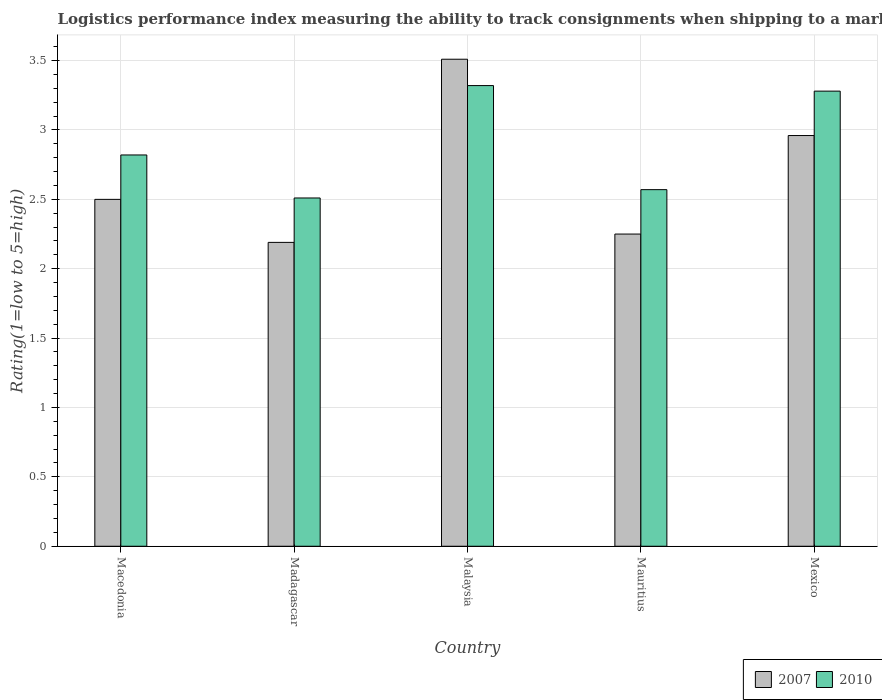How many groups of bars are there?
Provide a short and direct response. 5. How many bars are there on the 1st tick from the left?
Ensure brevity in your answer.  2. How many bars are there on the 1st tick from the right?
Offer a very short reply. 2. What is the label of the 3rd group of bars from the left?
Your answer should be compact. Malaysia. In how many cases, is the number of bars for a given country not equal to the number of legend labels?
Provide a succinct answer. 0. What is the Logistic performance index in 2007 in Mauritius?
Keep it short and to the point. 2.25. Across all countries, what is the maximum Logistic performance index in 2007?
Your answer should be very brief. 3.51. Across all countries, what is the minimum Logistic performance index in 2007?
Provide a short and direct response. 2.19. In which country was the Logistic performance index in 2007 maximum?
Your answer should be very brief. Malaysia. In which country was the Logistic performance index in 2010 minimum?
Give a very brief answer. Madagascar. What is the total Logistic performance index in 2007 in the graph?
Give a very brief answer. 13.41. What is the difference between the Logistic performance index in 2007 in Mauritius and that in Mexico?
Provide a short and direct response. -0.71. What is the difference between the Logistic performance index in 2010 in Macedonia and the Logistic performance index in 2007 in Madagascar?
Your answer should be very brief. 0.63. What is the average Logistic performance index in 2010 per country?
Your response must be concise. 2.9. What is the difference between the Logistic performance index of/in 2010 and Logistic performance index of/in 2007 in Malaysia?
Offer a very short reply. -0.19. In how many countries, is the Logistic performance index in 2007 greater than 2.8?
Ensure brevity in your answer.  2. What is the ratio of the Logistic performance index in 2007 in Mauritius to that in Mexico?
Provide a succinct answer. 0.76. Is the difference between the Logistic performance index in 2010 in Macedonia and Mexico greater than the difference between the Logistic performance index in 2007 in Macedonia and Mexico?
Give a very brief answer. No. What is the difference between the highest and the second highest Logistic performance index in 2010?
Ensure brevity in your answer.  0.46. What is the difference between the highest and the lowest Logistic performance index in 2010?
Give a very brief answer. 0.81. In how many countries, is the Logistic performance index in 2010 greater than the average Logistic performance index in 2010 taken over all countries?
Your answer should be very brief. 2. Is the sum of the Logistic performance index in 2007 in Malaysia and Mexico greater than the maximum Logistic performance index in 2010 across all countries?
Ensure brevity in your answer.  Yes. Are all the bars in the graph horizontal?
Keep it short and to the point. No. What is the difference between two consecutive major ticks on the Y-axis?
Provide a short and direct response. 0.5. How many legend labels are there?
Your answer should be very brief. 2. What is the title of the graph?
Keep it short and to the point. Logistics performance index measuring the ability to track consignments when shipping to a market. Does "1995" appear as one of the legend labels in the graph?
Offer a terse response. No. What is the label or title of the Y-axis?
Provide a short and direct response. Rating(1=low to 5=high). What is the Rating(1=low to 5=high) in 2010 in Macedonia?
Offer a very short reply. 2.82. What is the Rating(1=low to 5=high) in 2007 in Madagascar?
Provide a short and direct response. 2.19. What is the Rating(1=low to 5=high) in 2010 in Madagascar?
Provide a succinct answer. 2.51. What is the Rating(1=low to 5=high) of 2007 in Malaysia?
Your answer should be compact. 3.51. What is the Rating(1=low to 5=high) of 2010 in Malaysia?
Provide a succinct answer. 3.32. What is the Rating(1=low to 5=high) in 2007 in Mauritius?
Offer a very short reply. 2.25. What is the Rating(1=low to 5=high) of 2010 in Mauritius?
Give a very brief answer. 2.57. What is the Rating(1=low to 5=high) of 2007 in Mexico?
Offer a very short reply. 2.96. What is the Rating(1=low to 5=high) in 2010 in Mexico?
Provide a short and direct response. 3.28. Across all countries, what is the maximum Rating(1=low to 5=high) in 2007?
Offer a very short reply. 3.51. Across all countries, what is the maximum Rating(1=low to 5=high) of 2010?
Give a very brief answer. 3.32. Across all countries, what is the minimum Rating(1=low to 5=high) in 2007?
Ensure brevity in your answer.  2.19. Across all countries, what is the minimum Rating(1=low to 5=high) in 2010?
Keep it short and to the point. 2.51. What is the total Rating(1=low to 5=high) of 2007 in the graph?
Make the answer very short. 13.41. What is the difference between the Rating(1=low to 5=high) in 2007 in Macedonia and that in Madagascar?
Provide a succinct answer. 0.31. What is the difference between the Rating(1=low to 5=high) of 2010 in Macedonia and that in Madagascar?
Make the answer very short. 0.31. What is the difference between the Rating(1=low to 5=high) of 2007 in Macedonia and that in Malaysia?
Provide a succinct answer. -1.01. What is the difference between the Rating(1=low to 5=high) in 2007 in Macedonia and that in Mauritius?
Your answer should be compact. 0.25. What is the difference between the Rating(1=low to 5=high) of 2010 in Macedonia and that in Mauritius?
Make the answer very short. 0.25. What is the difference between the Rating(1=low to 5=high) in 2007 in Macedonia and that in Mexico?
Ensure brevity in your answer.  -0.46. What is the difference between the Rating(1=low to 5=high) of 2010 in Macedonia and that in Mexico?
Your response must be concise. -0.46. What is the difference between the Rating(1=low to 5=high) of 2007 in Madagascar and that in Malaysia?
Your answer should be very brief. -1.32. What is the difference between the Rating(1=low to 5=high) of 2010 in Madagascar and that in Malaysia?
Provide a short and direct response. -0.81. What is the difference between the Rating(1=low to 5=high) of 2007 in Madagascar and that in Mauritius?
Offer a very short reply. -0.06. What is the difference between the Rating(1=low to 5=high) of 2010 in Madagascar and that in Mauritius?
Keep it short and to the point. -0.06. What is the difference between the Rating(1=low to 5=high) in 2007 in Madagascar and that in Mexico?
Your answer should be compact. -0.77. What is the difference between the Rating(1=low to 5=high) of 2010 in Madagascar and that in Mexico?
Provide a succinct answer. -0.77. What is the difference between the Rating(1=low to 5=high) of 2007 in Malaysia and that in Mauritius?
Your response must be concise. 1.26. What is the difference between the Rating(1=low to 5=high) in 2010 in Malaysia and that in Mauritius?
Provide a succinct answer. 0.75. What is the difference between the Rating(1=low to 5=high) in 2007 in Malaysia and that in Mexico?
Your answer should be compact. 0.55. What is the difference between the Rating(1=low to 5=high) in 2007 in Mauritius and that in Mexico?
Your answer should be compact. -0.71. What is the difference between the Rating(1=low to 5=high) in 2010 in Mauritius and that in Mexico?
Give a very brief answer. -0.71. What is the difference between the Rating(1=low to 5=high) in 2007 in Macedonia and the Rating(1=low to 5=high) in 2010 in Madagascar?
Your answer should be compact. -0.01. What is the difference between the Rating(1=low to 5=high) in 2007 in Macedonia and the Rating(1=low to 5=high) in 2010 in Malaysia?
Give a very brief answer. -0.82. What is the difference between the Rating(1=low to 5=high) in 2007 in Macedonia and the Rating(1=low to 5=high) in 2010 in Mauritius?
Offer a very short reply. -0.07. What is the difference between the Rating(1=low to 5=high) of 2007 in Macedonia and the Rating(1=low to 5=high) of 2010 in Mexico?
Make the answer very short. -0.78. What is the difference between the Rating(1=low to 5=high) of 2007 in Madagascar and the Rating(1=low to 5=high) of 2010 in Malaysia?
Your answer should be very brief. -1.13. What is the difference between the Rating(1=low to 5=high) of 2007 in Madagascar and the Rating(1=low to 5=high) of 2010 in Mauritius?
Your response must be concise. -0.38. What is the difference between the Rating(1=low to 5=high) in 2007 in Madagascar and the Rating(1=low to 5=high) in 2010 in Mexico?
Ensure brevity in your answer.  -1.09. What is the difference between the Rating(1=low to 5=high) in 2007 in Malaysia and the Rating(1=low to 5=high) in 2010 in Mauritius?
Your response must be concise. 0.94. What is the difference between the Rating(1=low to 5=high) in 2007 in Malaysia and the Rating(1=low to 5=high) in 2010 in Mexico?
Your answer should be very brief. 0.23. What is the difference between the Rating(1=low to 5=high) of 2007 in Mauritius and the Rating(1=low to 5=high) of 2010 in Mexico?
Your answer should be very brief. -1.03. What is the average Rating(1=low to 5=high) of 2007 per country?
Provide a succinct answer. 2.68. What is the difference between the Rating(1=low to 5=high) of 2007 and Rating(1=low to 5=high) of 2010 in Macedonia?
Your response must be concise. -0.32. What is the difference between the Rating(1=low to 5=high) of 2007 and Rating(1=low to 5=high) of 2010 in Madagascar?
Give a very brief answer. -0.32. What is the difference between the Rating(1=low to 5=high) of 2007 and Rating(1=low to 5=high) of 2010 in Malaysia?
Make the answer very short. 0.19. What is the difference between the Rating(1=low to 5=high) in 2007 and Rating(1=low to 5=high) in 2010 in Mauritius?
Keep it short and to the point. -0.32. What is the difference between the Rating(1=low to 5=high) of 2007 and Rating(1=low to 5=high) of 2010 in Mexico?
Provide a short and direct response. -0.32. What is the ratio of the Rating(1=low to 5=high) in 2007 in Macedonia to that in Madagascar?
Your answer should be compact. 1.14. What is the ratio of the Rating(1=low to 5=high) in 2010 in Macedonia to that in Madagascar?
Ensure brevity in your answer.  1.12. What is the ratio of the Rating(1=low to 5=high) of 2007 in Macedonia to that in Malaysia?
Provide a short and direct response. 0.71. What is the ratio of the Rating(1=low to 5=high) in 2010 in Macedonia to that in Malaysia?
Your answer should be compact. 0.85. What is the ratio of the Rating(1=low to 5=high) of 2010 in Macedonia to that in Mauritius?
Your answer should be compact. 1.1. What is the ratio of the Rating(1=low to 5=high) of 2007 in Macedonia to that in Mexico?
Ensure brevity in your answer.  0.84. What is the ratio of the Rating(1=low to 5=high) in 2010 in Macedonia to that in Mexico?
Offer a terse response. 0.86. What is the ratio of the Rating(1=low to 5=high) of 2007 in Madagascar to that in Malaysia?
Offer a very short reply. 0.62. What is the ratio of the Rating(1=low to 5=high) in 2010 in Madagascar to that in Malaysia?
Make the answer very short. 0.76. What is the ratio of the Rating(1=low to 5=high) in 2007 in Madagascar to that in Mauritius?
Provide a succinct answer. 0.97. What is the ratio of the Rating(1=low to 5=high) in 2010 in Madagascar to that in Mauritius?
Make the answer very short. 0.98. What is the ratio of the Rating(1=low to 5=high) of 2007 in Madagascar to that in Mexico?
Offer a very short reply. 0.74. What is the ratio of the Rating(1=low to 5=high) in 2010 in Madagascar to that in Mexico?
Make the answer very short. 0.77. What is the ratio of the Rating(1=low to 5=high) of 2007 in Malaysia to that in Mauritius?
Offer a very short reply. 1.56. What is the ratio of the Rating(1=low to 5=high) of 2010 in Malaysia to that in Mauritius?
Your answer should be compact. 1.29. What is the ratio of the Rating(1=low to 5=high) in 2007 in Malaysia to that in Mexico?
Offer a very short reply. 1.19. What is the ratio of the Rating(1=low to 5=high) in 2010 in Malaysia to that in Mexico?
Offer a terse response. 1.01. What is the ratio of the Rating(1=low to 5=high) of 2007 in Mauritius to that in Mexico?
Offer a very short reply. 0.76. What is the ratio of the Rating(1=low to 5=high) of 2010 in Mauritius to that in Mexico?
Offer a very short reply. 0.78. What is the difference between the highest and the second highest Rating(1=low to 5=high) of 2007?
Your response must be concise. 0.55. What is the difference between the highest and the second highest Rating(1=low to 5=high) of 2010?
Your answer should be very brief. 0.04. What is the difference between the highest and the lowest Rating(1=low to 5=high) of 2007?
Provide a succinct answer. 1.32. What is the difference between the highest and the lowest Rating(1=low to 5=high) of 2010?
Provide a short and direct response. 0.81. 